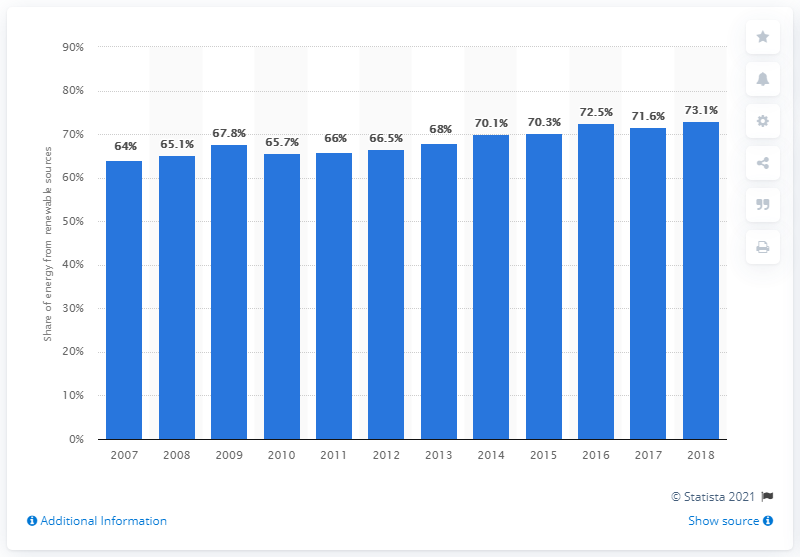List a handful of essential elements in this visual. In Austria, the percentage of renewable energy in electricity generation increased from 64% in 2007 to 74% in 2018. In Austria, the percentage of renewable energy in electricity generation increased from 2007 to 2018. During this period, the contribution of renewable energy to electricity generation was 73.1% in 2018. 